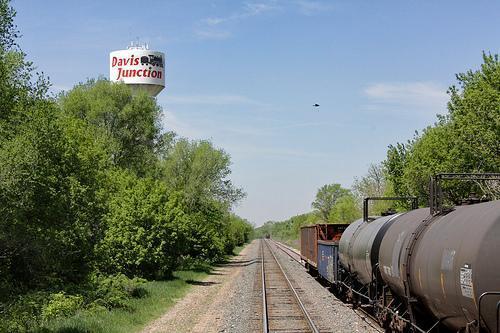How many tanks are there?
Give a very brief answer. 3. How many train tracks are shown?
Give a very brief answer. 2. 